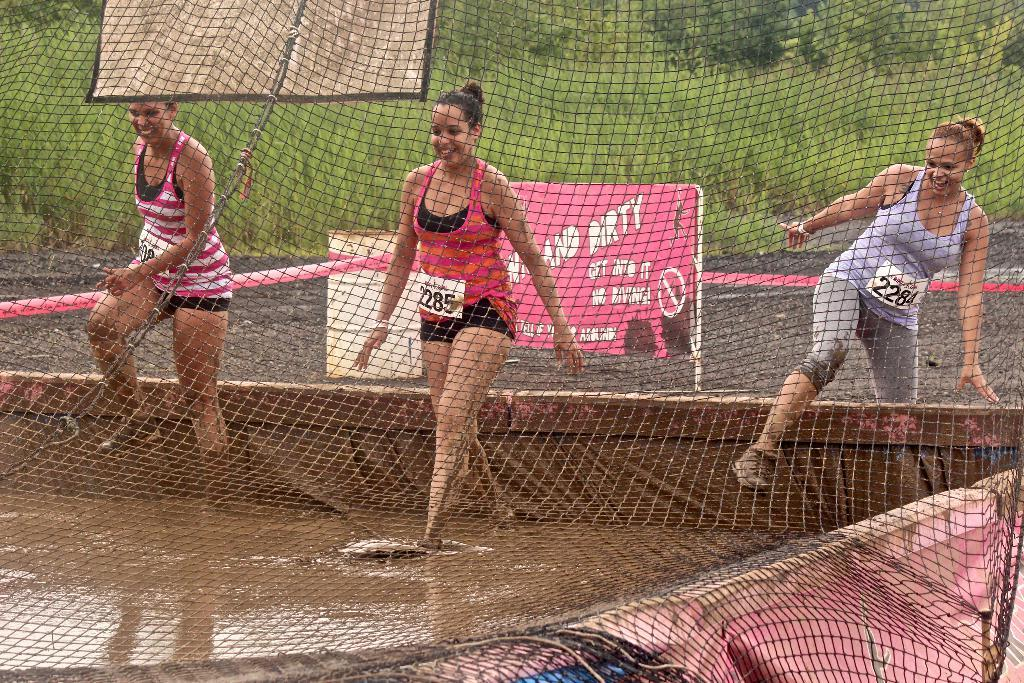Provide a one-sentence caption for the provided image. Three women are stepping into a vat of muddy water in front of a sign saying not to dive in. 